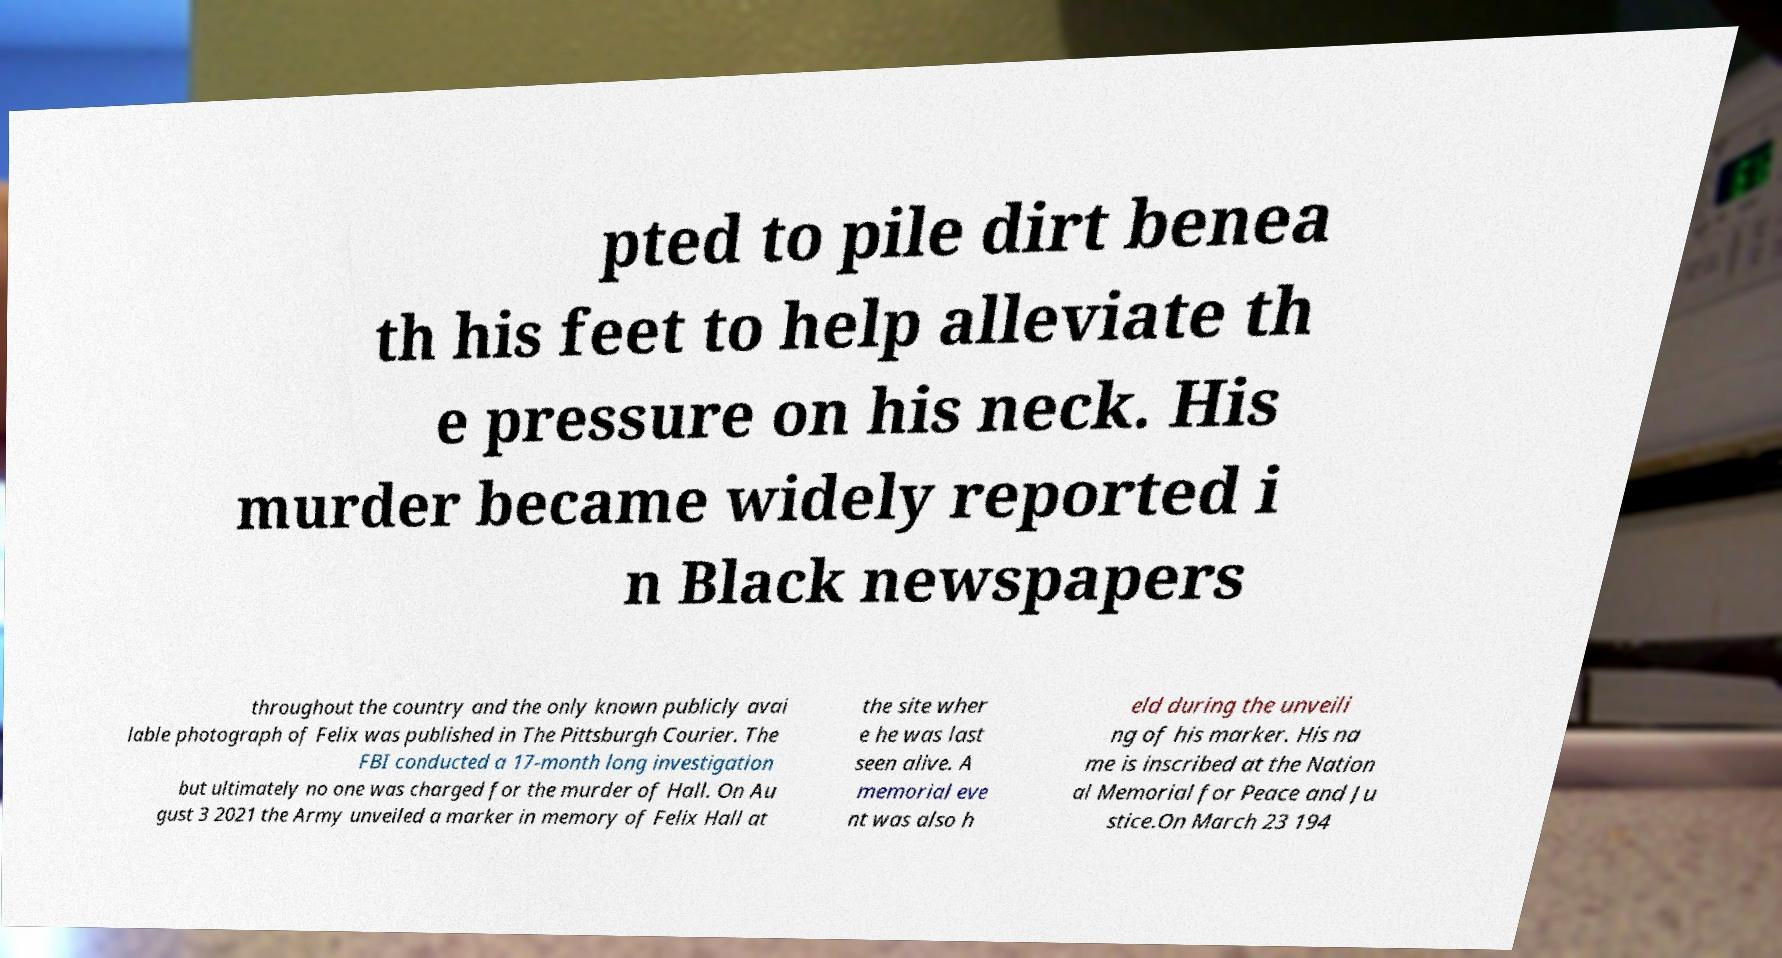Could you extract and type out the text from this image? pted to pile dirt benea th his feet to help alleviate th e pressure on his neck. His murder became widely reported i n Black newspapers throughout the country and the only known publicly avai lable photograph of Felix was published in The Pittsburgh Courier. The FBI conducted a 17-month long investigation but ultimately no one was charged for the murder of Hall. On Au gust 3 2021 the Army unveiled a marker in memory of Felix Hall at the site wher e he was last seen alive. A memorial eve nt was also h eld during the unveili ng of his marker. His na me is inscribed at the Nation al Memorial for Peace and Ju stice.On March 23 194 